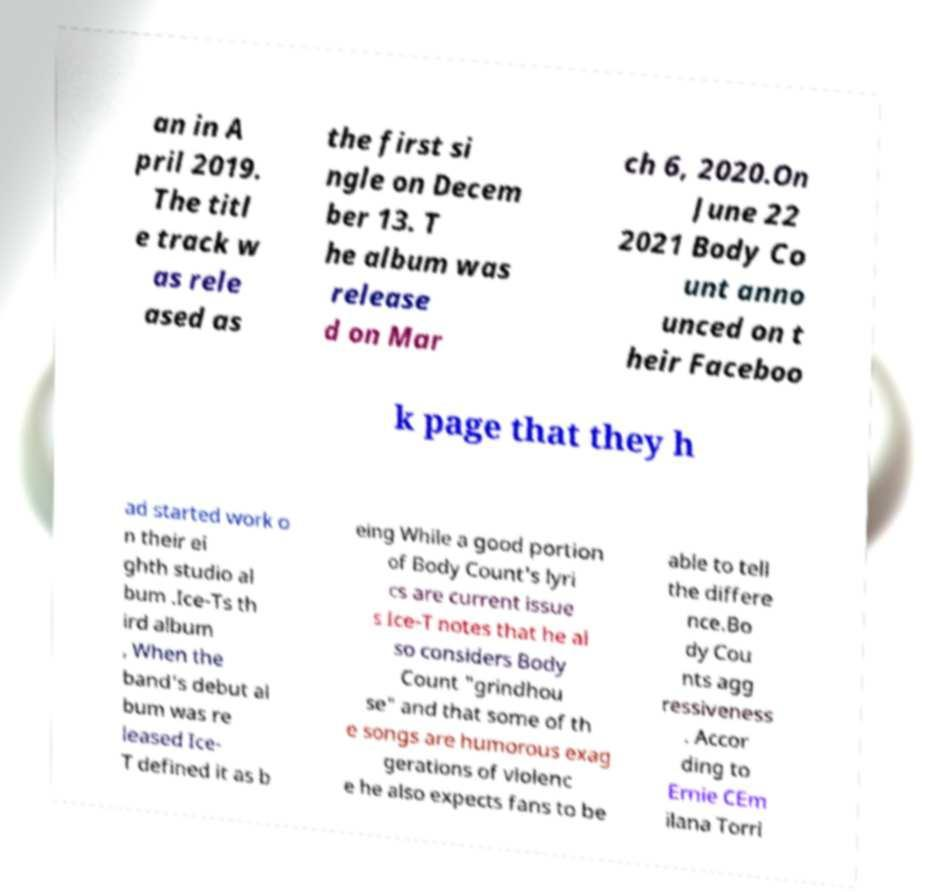I need the written content from this picture converted into text. Can you do that? an in A pril 2019. The titl e track w as rele ased as the first si ngle on Decem ber 13. T he album was release d on Mar ch 6, 2020.On June 22 2021 Body Co unt anno unced on t heir Faceboo k page that they h ad started work o n their ei ghth studio al bum .Ice-Ts th ird album , When the band's debut al bum was re leased Ice- T defined it as b eing While a good portion of Body Count's lyri cs are current issue s Ice-T notes that he al so considers Body Count "grindhou se" and that some of th e songs are humorous exag gerations of violenc e he also expects fans to be able to tell the differe nce.Bo dy Cou nts agg ressiveness . Accor ding to Ernie CEm ilana Torri 